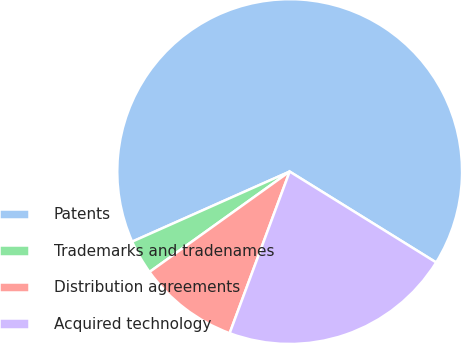Convert chart to OTSL. <chart><loc_0><loc_0><loc_500><loc_500><pie_chart><fcel>Patents<fcel>Trademarks and tradenames<fcel>Distribution agreements<fcel>Acquired technology<nl><fcel>65.5%<fcel>3.23%<fcel>9.45%<fcel>21.82%<nl></chart> 